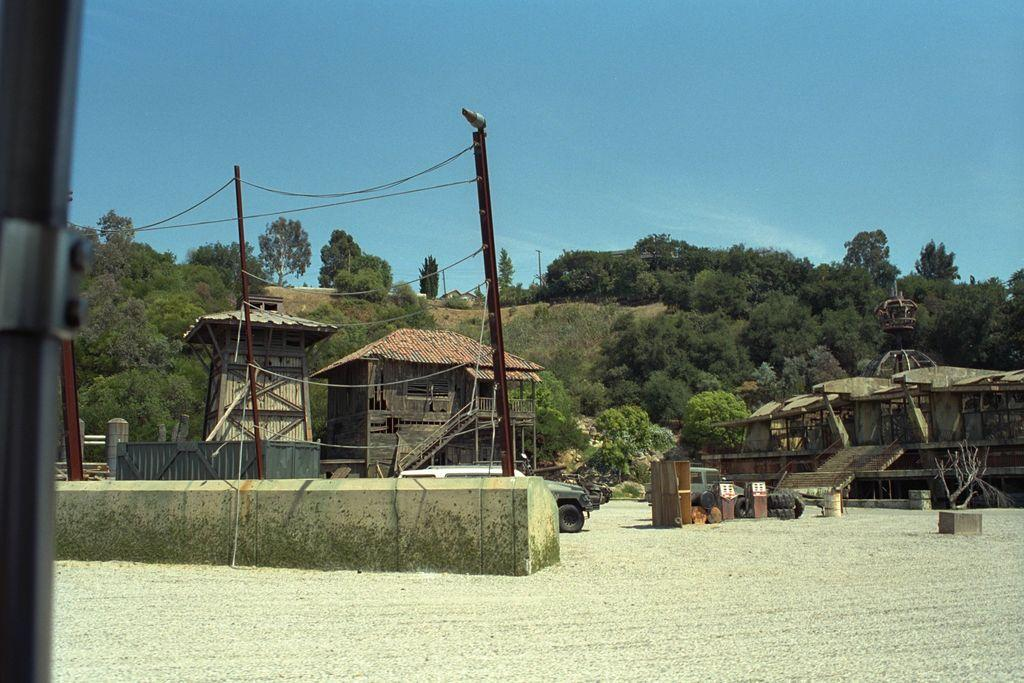What type of structures can be seen in the image? There are sheds in the image. What else can be seen in the image besides the sheds? There are vehicles, tyres, a wall, pillars, electric poles, and objects on the ground visible in the image. What is visible in the background of the image? There are trees and sky visible in the background of the image. Can you see any notes being passed between the fairies in the image? There are no fairies present in the image, so it is not possible to see any notes being passed between them. 